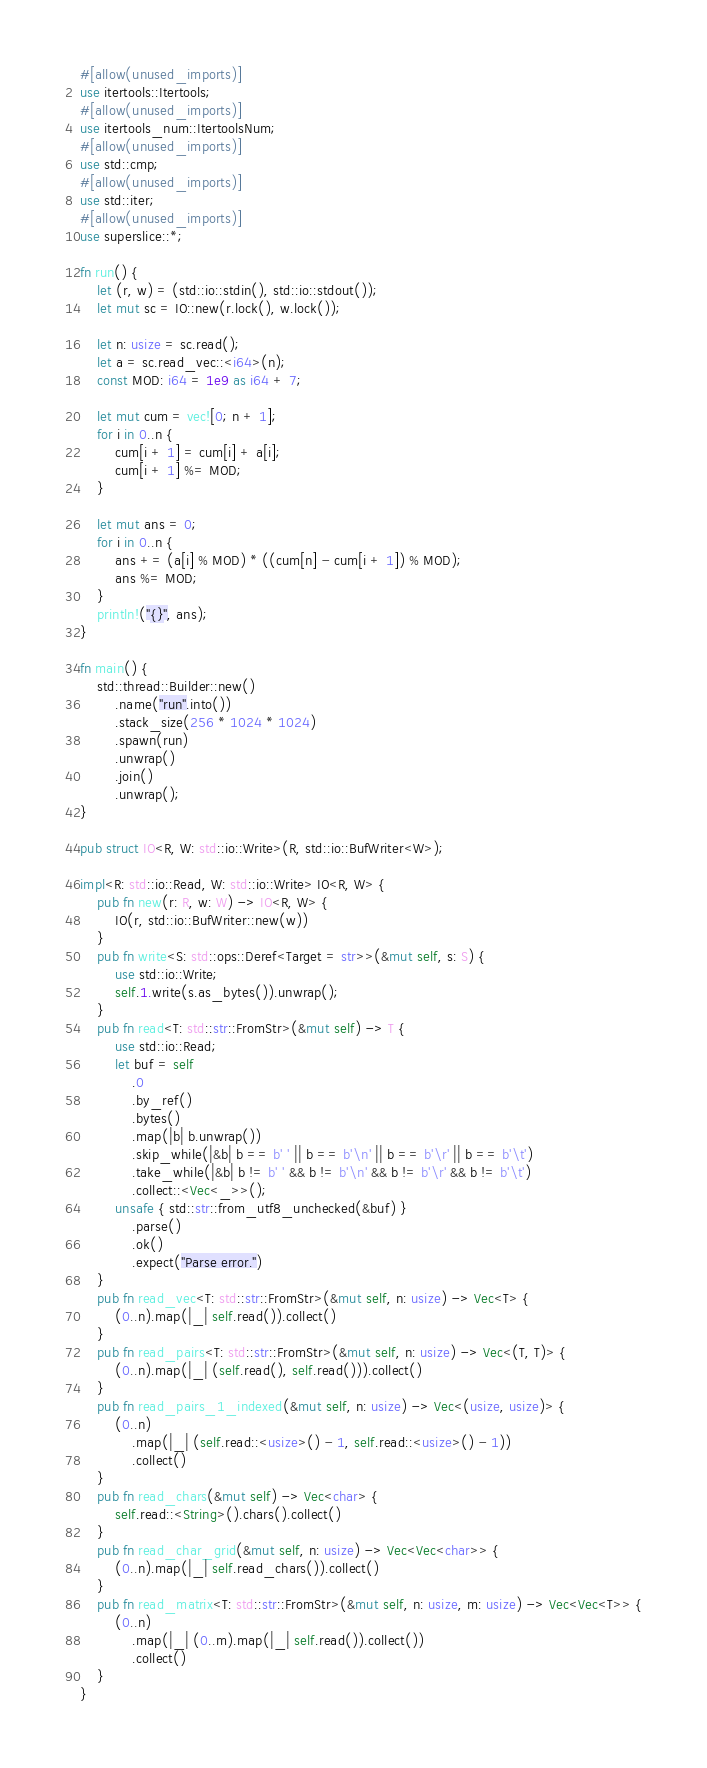<code> <loc_0><loc_0><loc_500><loc_500><_Rust_>#[allow(unused_imports)]
use itertools::Itertools;
#[allow(unused_imports)]
use itertools_num::ItertoolsNum;
#[allow(unused_imports)]
use std::cmp;
#[allow(unused_imports)]
use std::iter;
#[allow(unused_imports)]
use superslice::*;

fn run() {
    let (r, w) = (std::io::stdin(), std::io::stdout());
    let mut sc = IO::new(r.lock(), w.lock());

    let n: usize = sc.read();
    let a = sc.read_vec::<i64>(n);
    const MOD: i64 = 1e9 as i64 + 7;

    let mut cum = vec![0; n + 1];
    for i in 0..n {
        cum[i + 1] = cum[i] + a[i];
        cum[i + 1] %= MOD;
    }

    let mut ans = 0;
    for i in 0..n {
        ans += (a[i] % MOD) * ((cum[n] - cum[i + 1]) % MOD);
        ans %= MOD;
    }
    println!("{}", ans);
}

fn main() {
    std::thread::Builder::new()
        .name("run".into())
        .stack_size(256 * 1024 * 1024)
        .spawn(run)
        .unwrap()
        .join()
        .unwrap();
}

pub struct IO<R, W: std::io::Write>(R, std::io::BufWriter<W>);

impl<R: std::io::Read, W: std::io::Write> IO<R, W> {
    pub fn new(r: R, w: W) -> IO<R, W> {
        IO(r, std::io::BufWriter::new(w))
    }
    pub fn write<S: std::ops::Deref<Target = str>>(&mut self, s: S) {
        use std::io::Write;
        self.1.write(s.as_bytes()).unwrap();
    }
    pub fn read<T: std::str::FromStr>(&mut self) -> T {
        use std::io::Read;
        let buf = self
            .0
            .by_ref()
            .bytes()
            .map(|b| b.unwrap())
            .skip_while(|&b| b == b' ' || b == b'\n' || b == b'\r' || b == b'\t')
            .take_while(|&b| b != b' ' && b != b'\n' && b != b'\r' && b != b'\t')
            .collect::<Vec<_>>();
        unsafe { std::str::from_utf8_unchecked(&buf) }
            .parse()
            .ok()
            .expect("Parse error.")
    }
    pub fn read_vec<T: std::str::FromStr>(&mut self, n: usize) -> Vec<T> {
        (0..n).map(|_| self.read()).collect()
    }
    pub fn read_pairs<T: std::str::FromStr>(&mut self, n: usize) -> Vec<(T, T)> {
        (0..n).map(|_| (self.read(), self.read())).collect()
    }
    pub fn read_pairs_1_indexed(&mut self, n: usize) -> Vec<(usize, usize)> {
        (0..n)
            .map(|_| (self.read::<usize>() - 1, self.read::<usize>() - 1))
            .collect()
    }
    pub fn read_chars(&mut self) -> Vec<char> {
        self.read::<String>().chars().collect()
    }
    pub fn read_char_grid(&mut self, n: usize) -> Vec<Vec<char>> {
        (0..n).map(|_| self.read_chars()).collect()
    }
    pub fn read_matrix<T: std::str::FromStr>(&mut self, n: usize, m: usize) -> Vec<Vec<T>> {
        (0..n)
            .map(|_| (0..m).map(|_| self.read()).collect())
            .collect()
    }
}
</code> 